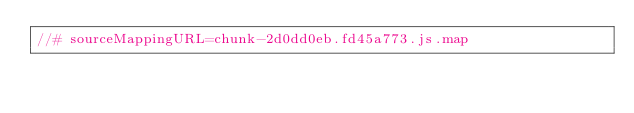Convert code to text. <code><loc_0><loc_0><loc_500><loc_500><_JavaScript_>//# sourceMappingURL=chunk-2d0dd0eb.fd45a773.js.map</code> 